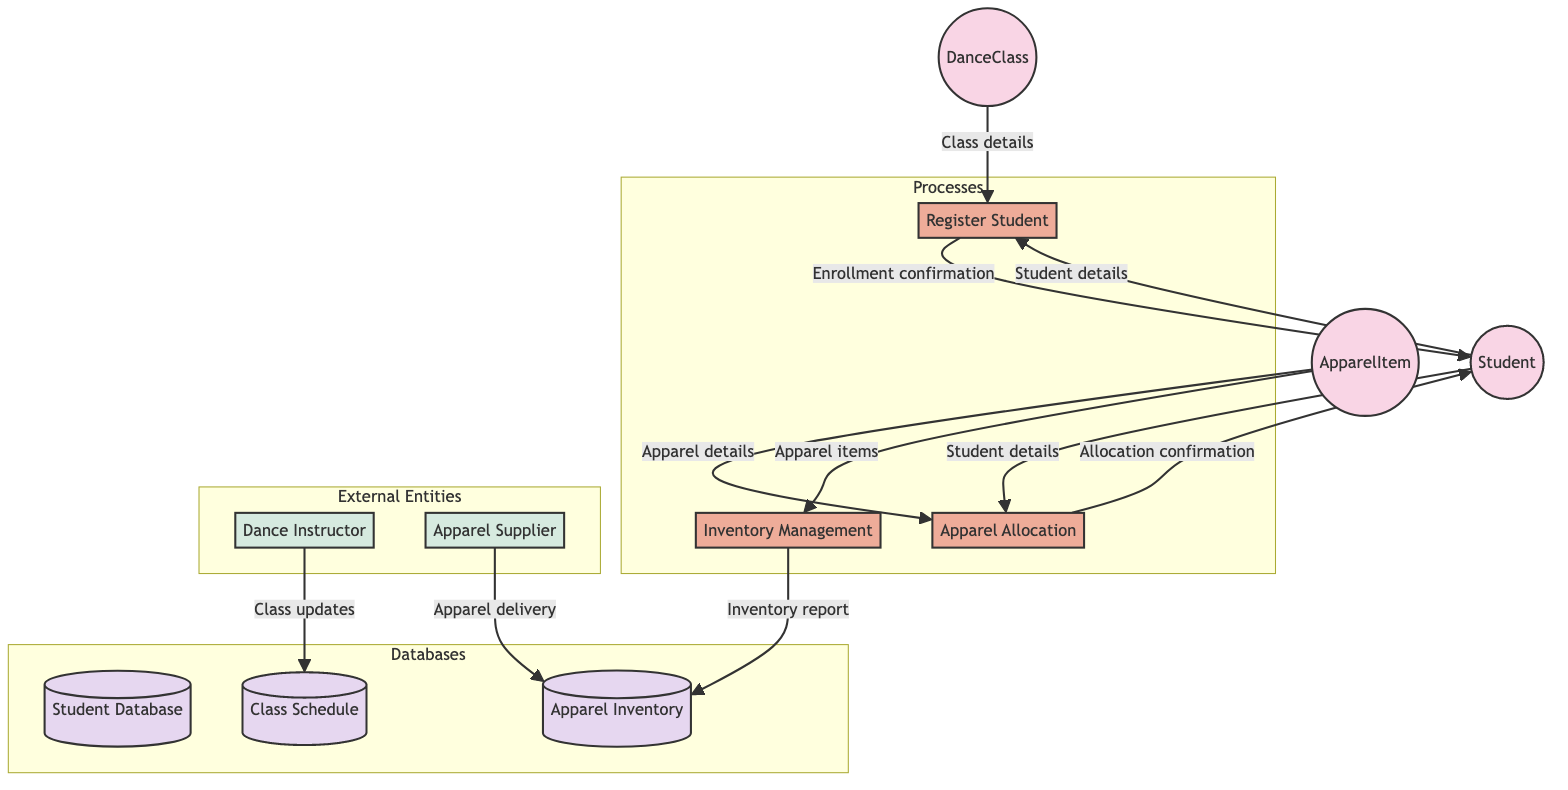What entity represents the students? The diagram shows "Student" as the entity representing individuals enrolling in dance classes.
Answer: Student How many processes are depicted in the diagram? The diagram contains three distinct processes: Register Student, Apparel Allocation, and Inventory Management.
Answer: 3 Which process handles the allocation of dance apparel? "Apparel Allocation" is clearly labeled as the process responsible for allocating the appropriate dance apparel to students.
Answer: Apparel Allocation What is the output of the Apparel Allocation process? The output of the Apparel Allocation process is "Apparel Allocation Confirmation," indicating that the allocation has been successfully processed.
Answer: Apparel Allocation Confirmation Which entity provides dance apparel supplies? The diagram shows "Apparel Supplier" as the external entity responsible for providing dance apparel items.
Answer: Apparel Supplier How does the student contribute to the Apparel Allocation process? The student provides necessary details to the Apparel Allocation process, allowing it to process the apparel allocation effectively.
Answer: Student details What type of information does the Inventory Management output? The Inventory Management process outputs "Inventory Report," documenting the status of apparel inventory items.
Answer: Inventory Report What is a necessary input for the Register Student process? The Register Student process requires inputs from both the "Student" and "DanceClass" entities to complete student enrollment.
Answer: Student and DanceClass How many external entities are included in the diagram? The diagram illustrates two external entities: Dance Instructor and Apparel Supplier, which interact with the system.
Answer: 2 